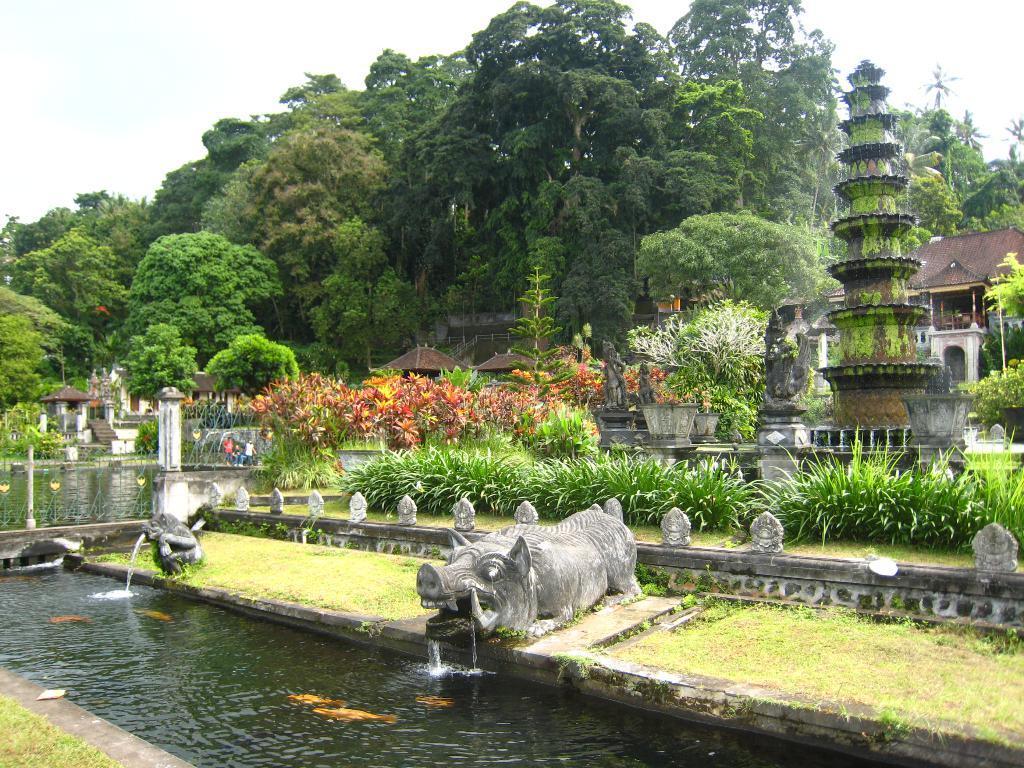Can you describe this image briefly? In the middle of the picture, we see the fountain statues with water fountain. Beside that, we see the grass. At the bottom, we see the water and the fishes are swimming in the water. There are trees, shrubs and plants in the middle. On the right side, we see a water fountain. There are buildings with a brown color roof. There are trees in the background. At the top, we see the sky. This picture is clicked in the park. 